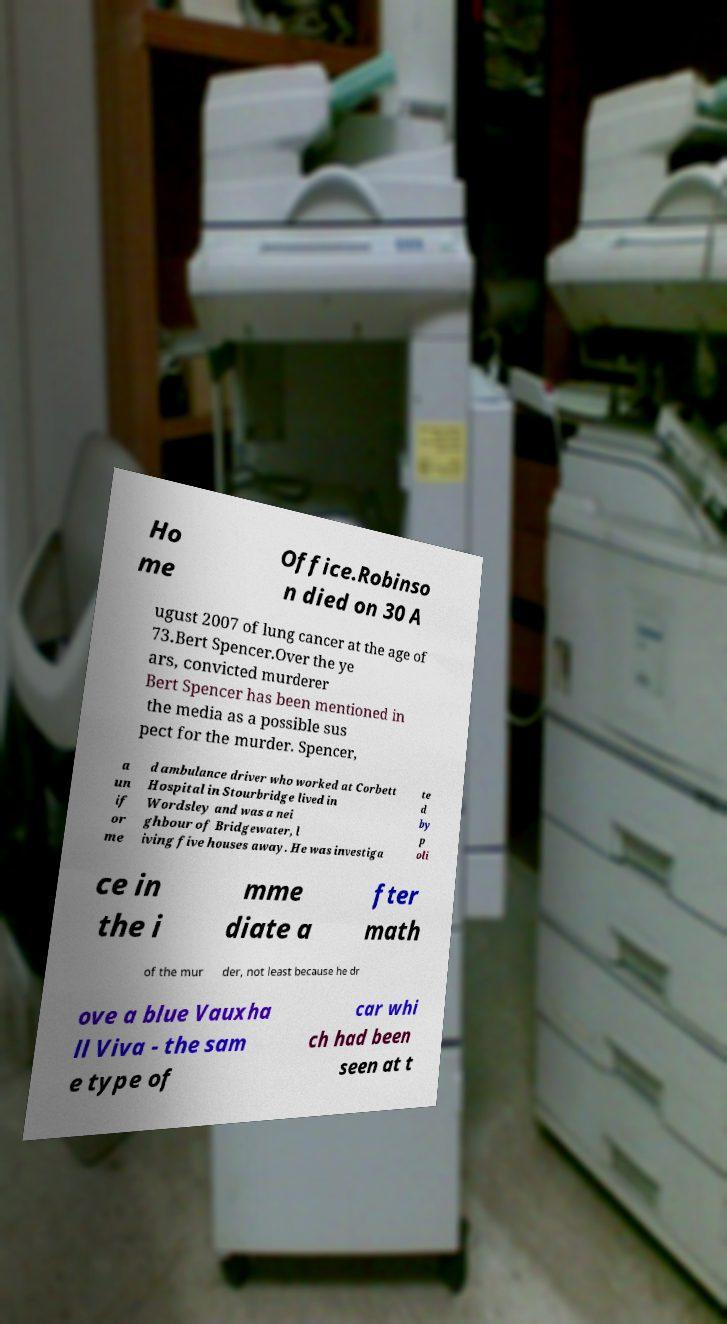Could you extract and type out the text from this image? Ho me Office.Robinso n died on 30 A ugust 2007 of lung cancer at the age of 73.Bert Spencer.Over the ye ars, convicted murderer Bert Spencer has been mentioned in the media as a possible sus pect for the murder. Spencer, a un if or me d ambulance driver who worked at Corbett Hospital in Stourbridge lived in Wordsley and was a nei ghbour of Bridgewater, l iving five houses away. He was investiga te d by p oli ce in the i mme diate a fter math of the mur der, not least because he dr ove a blue Vauxha ll Viva - the sam e type of car whi ch had been seen at t 